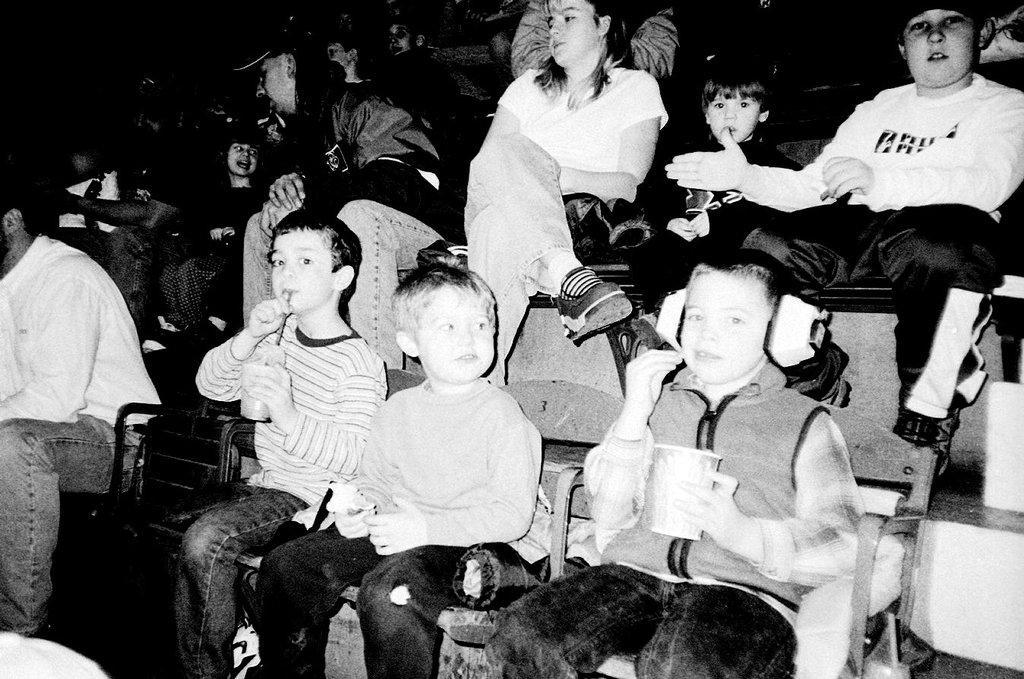In one or two sentences, can you explain what this image depicts? This is a black and white image. In this image, we can see a group of people sitting on the chair. In the left corner, we can also see an object. In the background, we can see black color. 